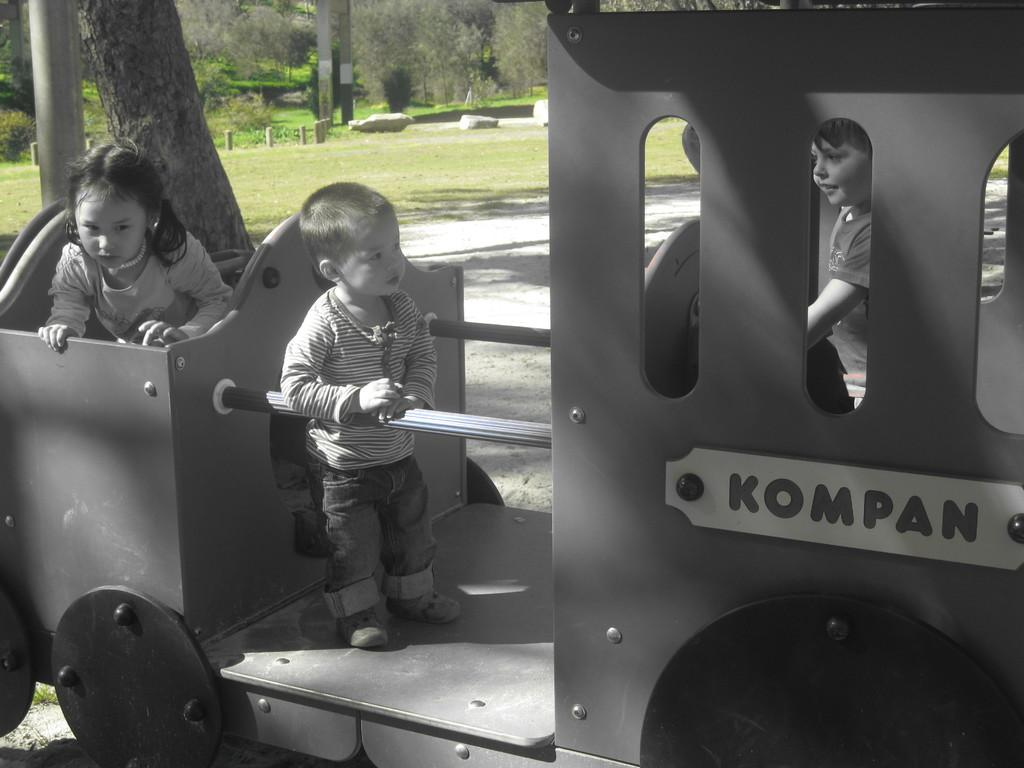What is happening in the image involving people? There are people in a vehicle in the image. What can be seen in the background of the image? There are trees, stones, and poles in the background of the image. What type of plants are being used as appliances in the image? There are no plants or appliances present in the image. How many babies are visible in the image? There are no babies visible in the image. 